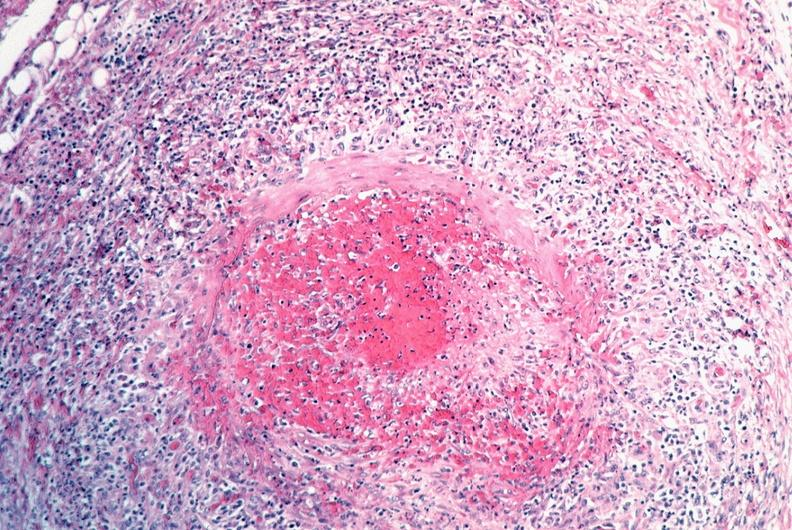s macerated stillborn present?
Answer the question using a single word or phrase. No 